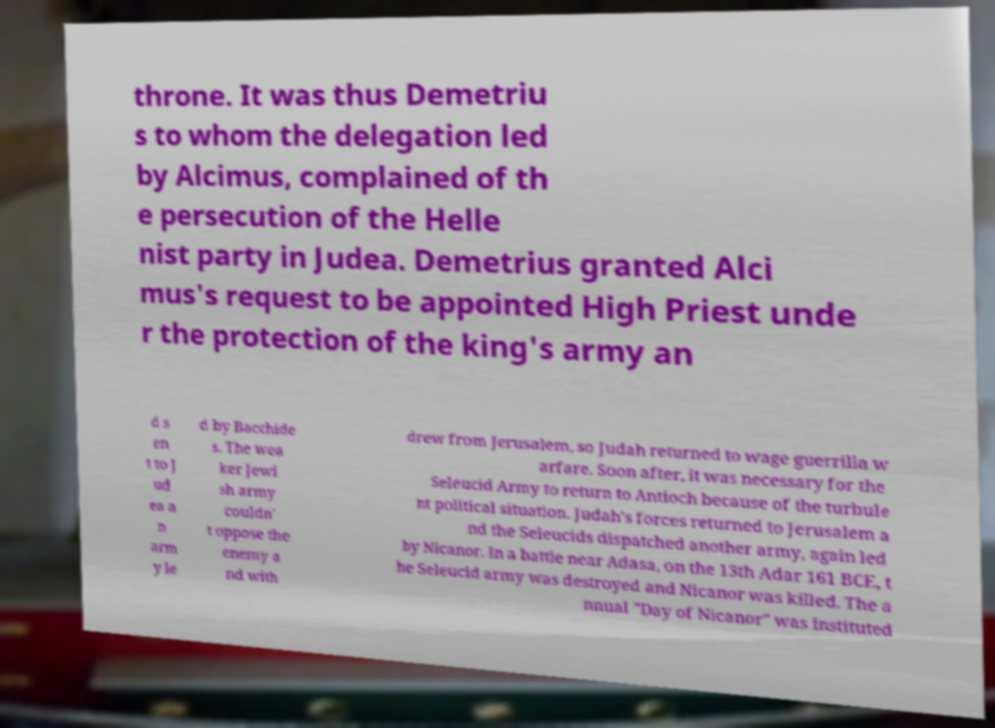Could you extract and type out the text from this image? throne. It was thus Demetriu s to whom the delegation led by Alcimus, complained of th e persecution of the Helle nist party in Judea. Demetrius granted Alci mus's request to be appointed High Priest unde r the protection of the king's army an d s en t to J ud ea a n arm y le d by Bacchide s. The wea ker Jewi sh army couldn' t oppose the enemy a nd with drew from Jerusalem, so Judah returned to wage guerrilla w arfare. Soon after, it was necessary for the Seleucid Army to return to Antioch because of the turbule nt political situation. Judah's forces returned to Jerusalem a nd the Seleucids dispatched another army, again led by Nicanor. In a battle near Adasa, on the 13th Adar 161 BCE, t he Seleucid army was destroyed and Nicanor was killed. The a nnual "Day of Nicanor" was instituted 